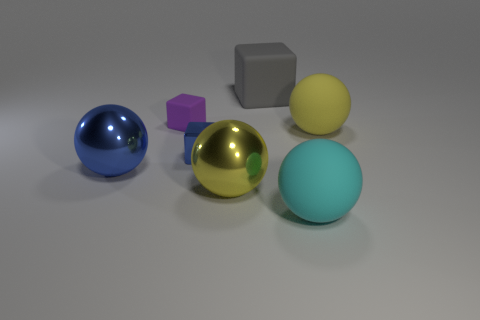Is the color of the big cube the same as the tiny shiny cube?
Ensure brevity in your answer.  No. There is a small shiny object; is its color the same as the matte thing to the left of the large yellow metal thing?
Your response must be concise. No. The shiny object that is the same color as the tiny metallic block is what shape?
Provide a short and direct response. Sphere. What is the material of the blue thing that is to the left of the blue shiny thing to the right of the big shiny ball that is behind the big yellow metallic sphere?
Your answer should be compact. Metal. There is a big metal thing that is behind the yellow metal object; does it have the same shape as the small blue thing?
Offer a very short reply. No. There is a large yellow object that is in front of the large blue thing; what is its material?
Make the answer very short. Metal. What number of matte things are either large gray blocks or big cyan objects?
Make the answer very short. 2. Are there any rubber spheres of the same size as the blue metallic sphere?
Ensure brevity in your answer.  Yes. Is the number of large rubber objects left of the cyan ball greater than the number of tiny rubber cylinders?
Give a very brief answer. Yes. How many tiny objects are either blue objects or rubber cylinders?
Keep it short and to the point. 1. 